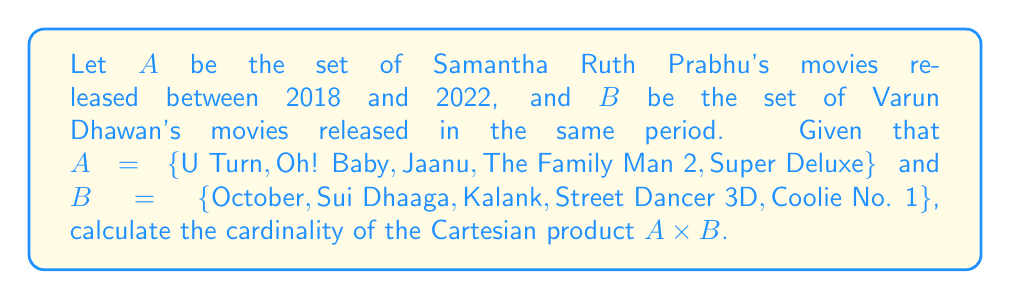Show me your answer to this math problem. To solve this problem, we need to understand the concept of Cartesian product and how to calculate its cardinality.

1. The Cartesian product of two sets $A$ and $B$, denoted as $A \times B$, is the set of all ordered pairs $(a, b)$ where $a \in A$ and $b \in B$.

2. The cardinality of a Cartesian product is given by the formula:

   $|A \times B| = |A| \cdot |B|$

   where $|A|$ represents the number of elements in set $A$, and $|B|$ represents the number of elements in set $B$.

3. Let's count the elements in each set:
   $|A| = 5$ (Samantha Ruth Prabhu's movies)
   $|B| = 5$ (Varun Dhawan's movies)

4. Now, we can apply the formula:

   $|A \times B| = |A| \cdot |B| = 5 \cdot 5 = 25$

This means that there are 25 possible combinations of Samantha Ruth Prabhu's movies and Varun Dhawan's movies in the given period.

Each element in this Cartesian product would be an ordered pair, such as (U Turn, October), (Oh! Baby, Sui Dhaaga), etc., representing all possible combinations of one movie from set $A$ and one movie from set $B$.
Answer: The cardinality of the Cartesian product $A \times B$ is 25. 